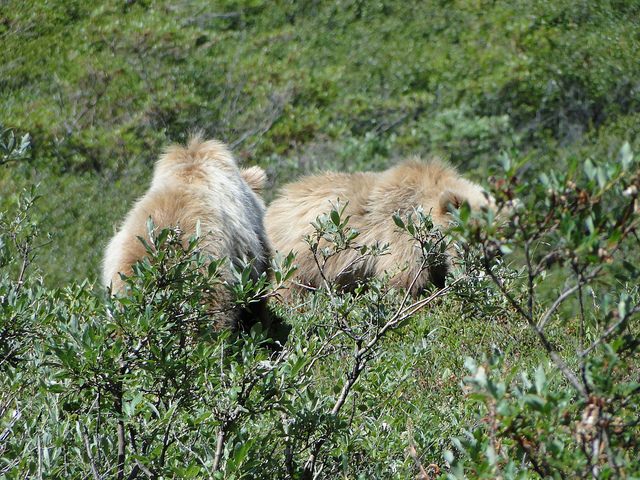How many animals are in the photo? There are two animals visible in the photo, both appearing to be in a natural, possibly wild setting, amid vegetation. 